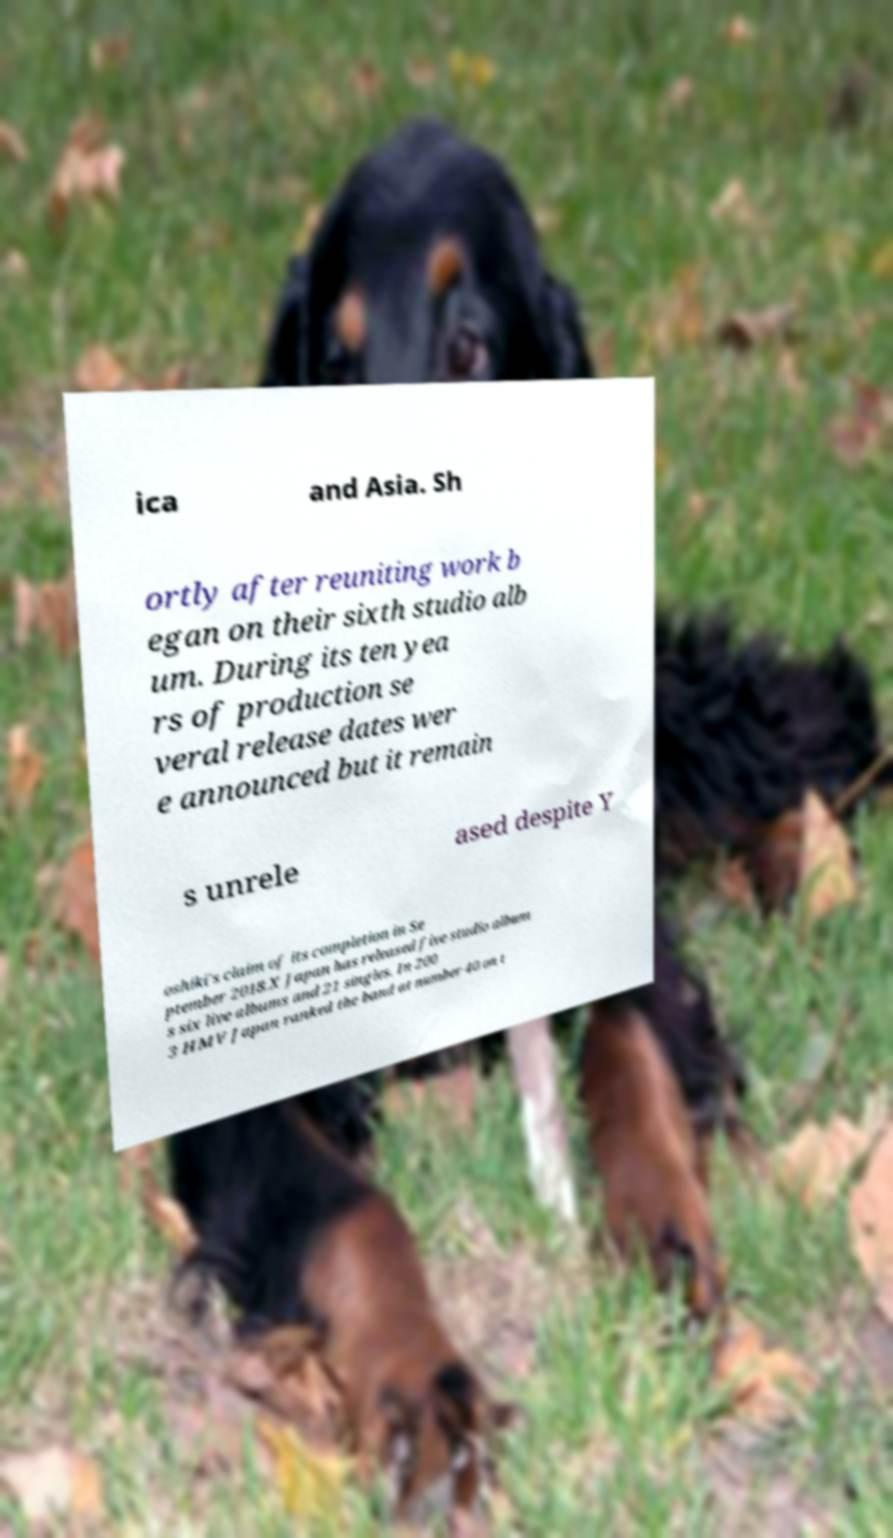There's text embedded in this image that I need extracted. Can you transcribe it verbatim? ica and Asia. Sh ortly after reuniting work b egan on their sixth studio alb um. During its ten yea rs of production se veral release dates wer e announced but it remain s unrele ased despite Y oshiki's claim of its completion in Se ptember 2018.X Japan has released five studio album s six live albums and 21 singles. In 200 3 HMV Japan ranked the band at number 40 on t 